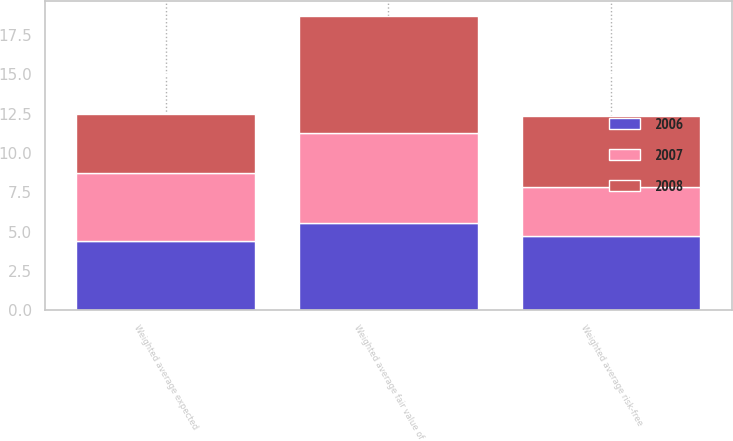<chart> <loc_0><loc_0><loc_500><loc_500><stacked_bar_chart><ecel><fcel>Weighted average fair value of<fcel>Weighted average risk-free<fcel>Weighted average expected<nl><fcel>2007<fcel>5.73<fcel>3.13<fcel>4.33<nl><fcel>2008<fcel>7.41<fcel>4.5<fcel>3.77<nl><fcel>2006<fcel>5.55<fcel>4.72<fcel>4.39<nl></chart> 